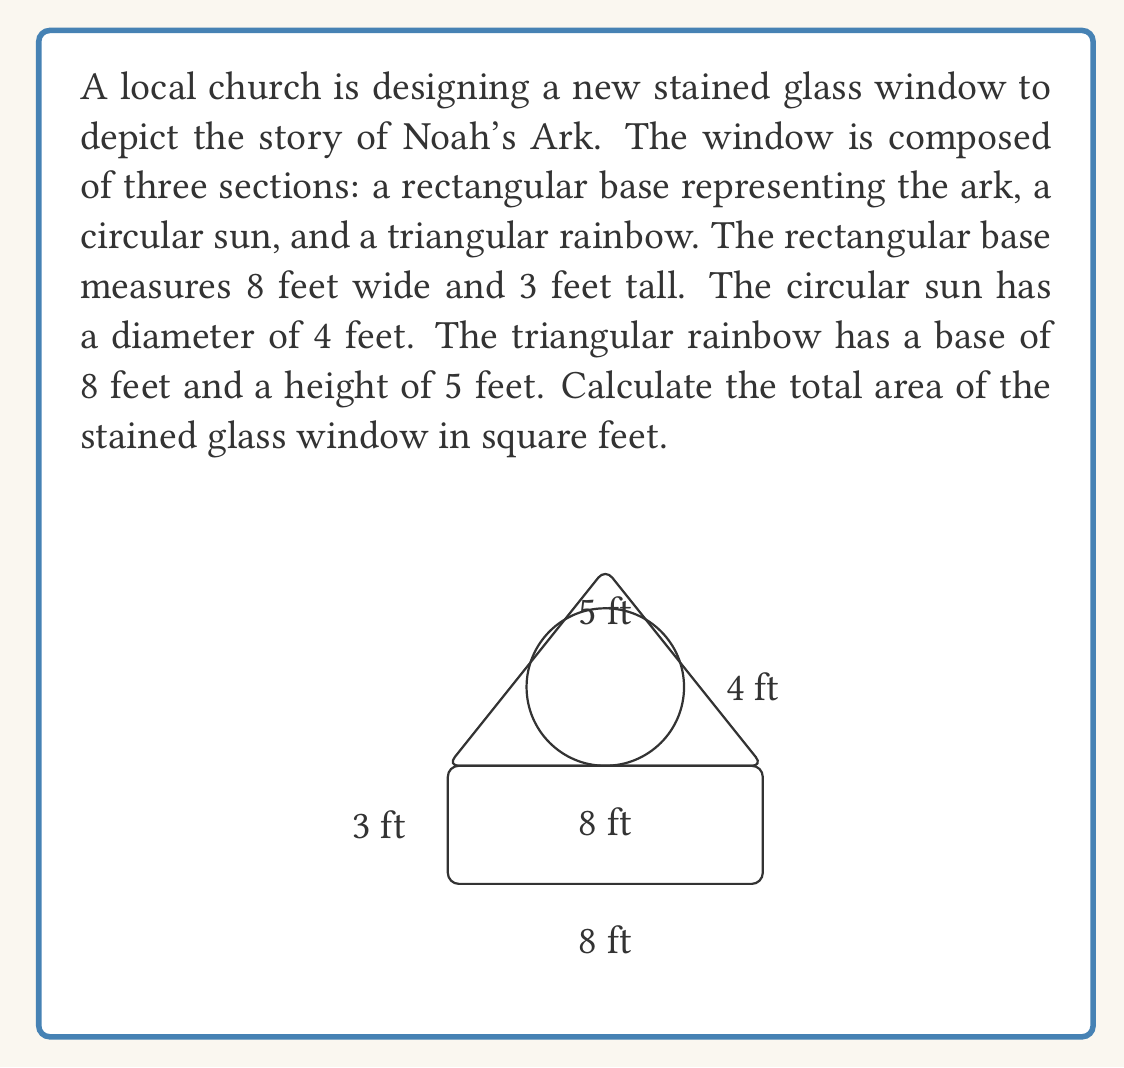Provide a solution to this math problem. To find the total area of the stained glass window, we need to calculate the areas of each component and sum them up:

1. Area of the rectangular base (ark):
   $$ A_{rectangle} = length \times width = 8 \times 3 = 24 \text{ sq ft} $$

2. Area of the circular sun:
   $$ A_{circle} = \pi r^2 = \pi \times 2^2 = 4\pi \text{ sq ft} $$

3. Area of the triangular rainbow:
   $$ A_{triangle} = \frac{1}{2} \times base \times height = \frac{1}{2} \times 8 \times 5 = 20 \text{ sq ft} $$

Now, we sum up all the areas:

$$ A_{total} = A_{rectangle} + A_{circle} + A_{triangle} $$
$$ A_{total} = 24 + 4\pi + 20 $$
$$ A_{total} = 44 + 4\pi \text{ sq ft} $$

To get a decimal approximation, we can use $\pi \approx 3.14159$:

$$ A_{total} \approx 44 + 4(3.14159) \approx 56.57 \text{ sq ft} $$
Answer: The total area of the stained glass window is $44 + 4\pi$ square feet, or approximately 56.57 square feet. 